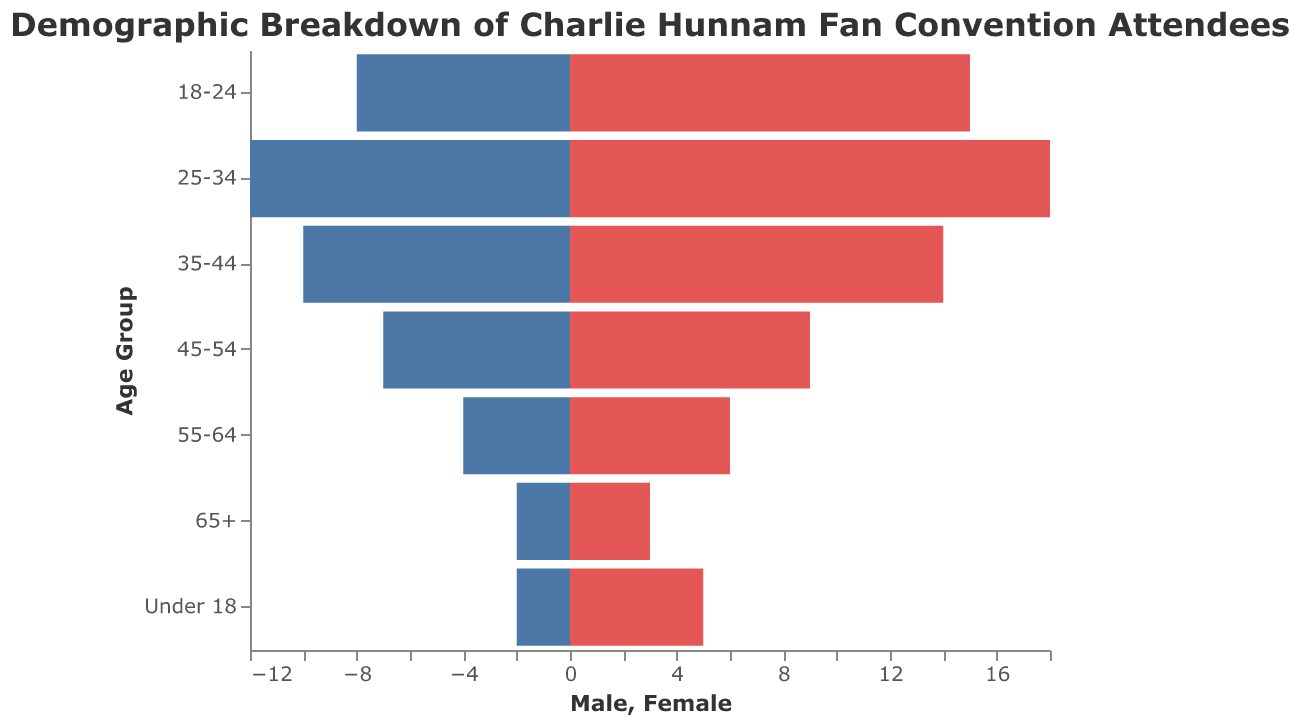What is the title of the figure? The title is a direct text element at the top of the figure indicating the main subject. It reads "Demographic Breakdown of Charlie Hunnam Fan Convention Attendees."
Answer: Demographic Breakdown of Charlie Hunnam Fan Convention Attendees Which age group has the highest number of female attendees? The highest number of female attendees can be seen visually by identifying the longest bar on the Female side of the pyramid. The 25-34 age group has the longest bar.
Answer: 25-34 What's the total number of attendees for the 35-44 age group? Add the number of male and female attendees in the 35-44 age group: 10 males + 14 females = 24.
Answer: 24 In which age group is the gender difference (Female - Male) the greatest? Calculate the difference between female and male attendees for each age group and compare. The greatest difference is in the 18-24 age group with a difference of 15 - 8 = 7.
Answer: 18-24 How many more female attendees are there than male attendees in the Under 18 age group? Subtraction of male attendees from female attendees in Under 18 age group: 5 females - 2 males = 3.
Answer: 3 What is the total number of male attendees across all age groups? Add the number of male attendees from all age groups: 2 + 8 + 12 + 10 + 7 + 4 + 2 = 45.
Answer: 45 Which age group has the smallest number of attendees? Identify the age group with the smallest combined male and female attendees. The 65+ age group has the smallest total with 5 attendees (2 males + 3 females).
Answer: 65+ Are there more male or female attendees in the 55-64 age group? Compare the number of male and female attendees: 55-64 has 4 males and 6 females. There are more females.
Answer: Female What is the age group with the most balanced gender representation? Find the age group where the difference between male and female attendees is the smallest. The 55-64 age group has a small difference of 2 (6 females - 4 males).
Answer: 55-64 How many total attendees are there for all age groups combined? Sum up the total attendees for all age groups for both genders: (2+5) + (8+15) + (12+18) + (10+14) + (7+9) + (4+6) + (2+3) = 115.
Answer: 115 